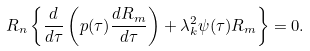Convert formula to latex. <formula><loc_0><loc_0><loc_500><loc_500>R _ { n } \left \{ \frac { d } { d \tau } \left ( p ( \tau ) \frac { d R _ { m } } { d \tau } \right ) + \lambda _ { k } ^ { 2 } \psi ( \tau ) R _ { m } \right \} = 0 .</formula> 